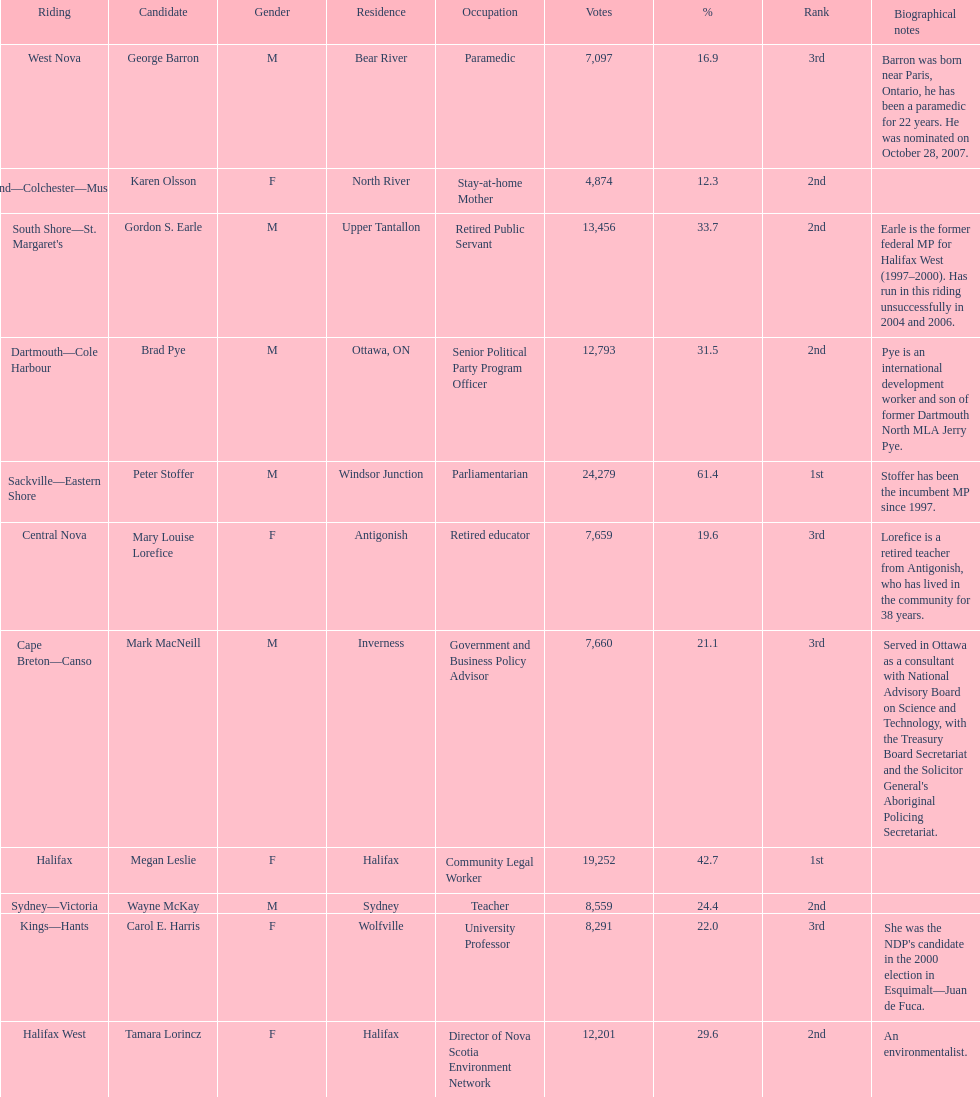Who has the greatest amount of votes? Sackville-Eastern Shore. Can you give me this table as a dict? {'header': ['Riding', 'Candidate', 'Gender', 'Residence', 'Occupation', 'Votes', '%', 'Rank', 'Biographical notes'], 'rows': [['West Nova', 'George Barron', 'M', 'Bear River', 'Paramedic', '7,097', '16.9', '3rd', 'Barron was born near Paris, Ontario, he has been a paramedic for 22 years. He was nominated on October 28, 2007.'], ['Cumberland—Colchester—Musquodoboit Valley', 'Karen Olsson', 'F', 'North River', 'Stay-at-home Mother', '4,874', '12.3', '2nd', ''], ["South Shore—St. Margaret's", 'Gordon S. Earle', 'M', 'Upper Tantallon', 'Retired Public Servant', '13,456', '33.7', '2nd', 'Earle is the former federal MP for Halifax West (1997–2000). Has run in this riding unsuccessfully in 2004 and 2006.'], ['Dartmouth—Cole Harbour', 'Brad Pye', 'M', 'Ottawa, ON', 'Senior Political Party Program Officer', '12,793', '31.5', '2nd', 'Pye is an international development worker and son of former Dartmouth North MLA Jerry Pye.'], ['Sackville—Eastern Shore', 'Peter Stoffer', 'M', 'Windsor Junction', 'Parliamentarian', '24,279', '61.4', '1st', 'Stoffer has been the incumbent MP since 1997.'], ['Central Nova', 'Mary Louise Lorefice', 'F', 'Antigonish', 'Retired educator', '7,659', '19.6', '3rd', 'Lorefice is a retired teacher from Antigonish, who has lived in the community for 38 years.'], ['Cape Breton—Canso', 'Mark MacNeill', 'M', 'Inverness', 'Government and Business Policy Advisor', '7,660', '21.1', '3rd', "Served in Ottawa as a consultant with National Advisory Board on Science and Technology, with the Treasury Board Secretariat and the Solicitor General's Aboriginal Policing Secretariat."], ['Halifax', 'Megan Leslie', 'F', 'Halifax', 'Community Legal Worker', '19,252', '42.7', '1st', ''], ['Sydney—Victoria', 'Wayne McKay', 'M', 'Sydney', 'Teacher', '8,559', '24.4', '2nd', ''], ['Kings—Hants', 'Carol E. Harris', 'F', 'Wolfville', 'University Professor', '8,291', '22.0', '3rd', "She was the NDP's candidate in the 2000 election in Esquimalt—Juan de Fuca."], ['Halifax West', 'Tamara Lorincz', 'F', 'Halifax', 'Director of Nova Scotia Environment Network', '12,201', '29.6', '2nd', 'An environmentalist.']]} 